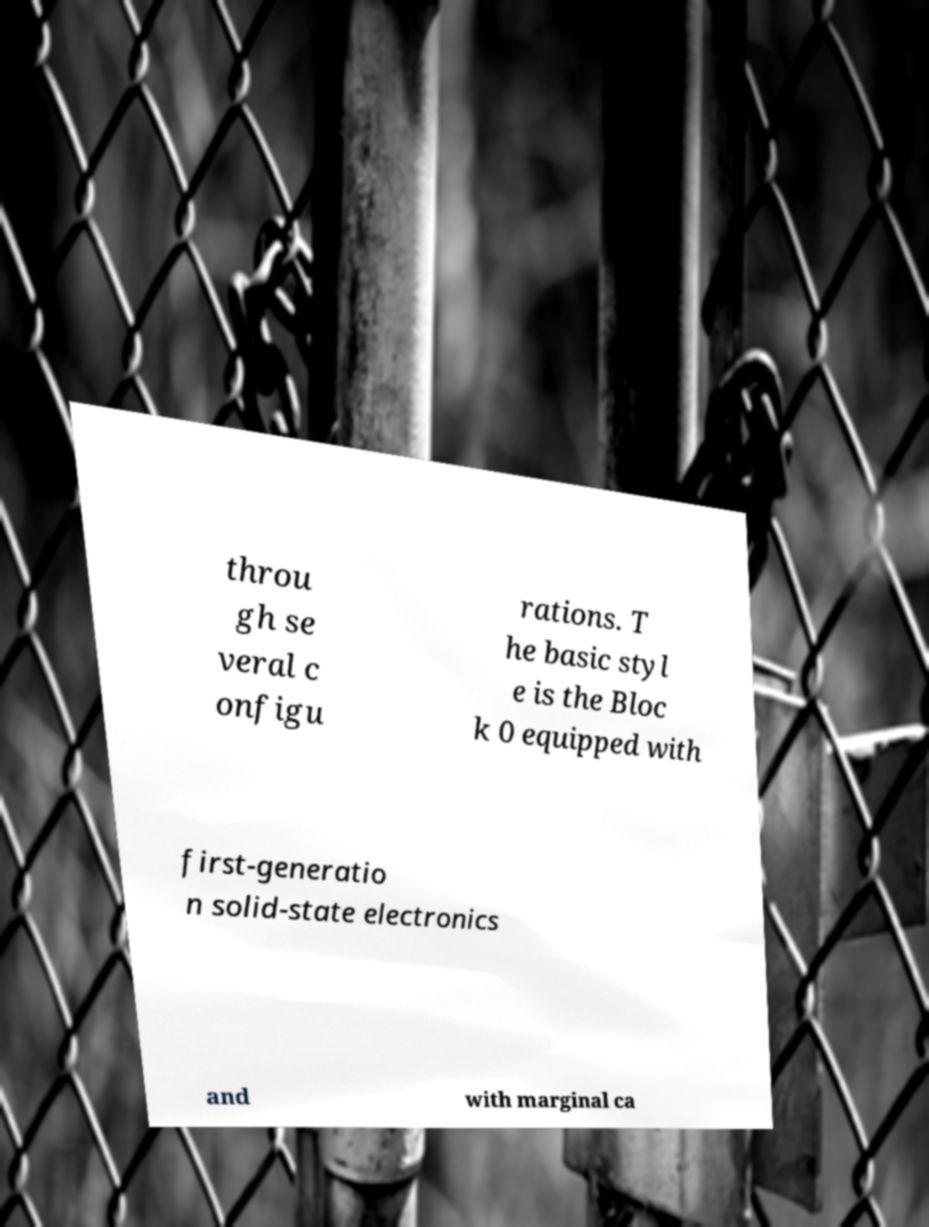Please identify and transcribe the text found in this image. throu gh se veral c onfigu rations. T he basic styl e is the Bloc k 0 equipped with first-generatio n solid-state electronics and with marginal ca 